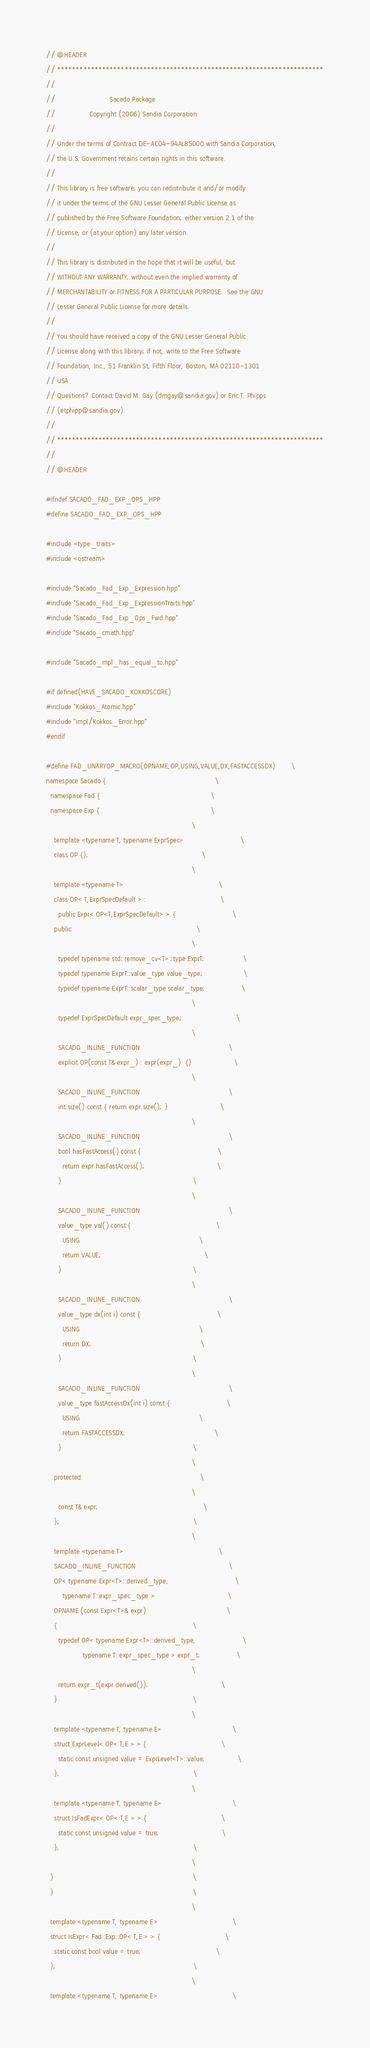<code> <loc_0><loc_0><loc_500><loc_500><_C++_>// @HEADER
// ***********************************************************************
//
//                           Sacado Package
//                 Copyright (2006) Sandia Corporation
//
// Under the terms of Contract DE-AC04-94AL85000 with Sandia Corporation,
// the U.S. Government retains certain rights in this software.
//
// This library is free software; you can redistribute it and/or modify
// it under the terms of the GNU Lesser General Public License as
// published by the Free Software Foundation; either version 2.1 of the
// License, or (at your option) any later version.
//
// This library is distributed in the hope that it will be useful, but
// WITHOUT ANY WARRANTY; without even the implied warranty of
// MERCHANTABILITY or FITNESS FOR A PARTICULAR PURPOSE.  See the GNU
// Lesser General Public License for more details.
//
// You should have received a copy of the GNU Lesser General Public
// License along with this library; if not, write to the Free Software
// Foundation, Inc., 51 Franklin St, Fifth Floor, Boston, MA 02110-1301
// USA
// Questions? Contact David M. Gay (dmgay@sandia.gov) or Eric T. Phipps
// (etphipp@sandia.gov).
//
// ***********************************************************************
//
// @HEADER

#ifndef SACADO_FAD_EXP_OPS_HPP
#define SACADO_FAD_EXP_OPS_HPP

#include <type_traits>
#include <ostream>

#include "Sacado_Fad_Exp_Expression.hpp"
#include "Sacado_Fad_Exp_ExpressionTraits.hpp"
#include "Sacado_Fad_Exp_Ops_Fwd.hpp"
#include "Sacado_cmath.hpp"

#include "Sacado_mpl_has_equal_to.hpp"

#if defined(HAVE_SACADO_KOKKOSCORE)
#include "Kokkos_Atomic.hpp"
#include "impl/Kokkos_Error.hpp"
#endif

#define FAD_UNARYOP_MACRO(OPNAME,OP,USING,VALUE,DX,FASTACCESSDX)        \
namespace Sacado {                                                      \
  namespace Fad {                                                       \
  namespace Exp {                                                       \
                                                                        \
    template <typename T, typename ExprSpec>                            \
    class OP {};                                                        \
                                                                        \
    template <typename T>                                               \
    class OP< T,ExprSpecDefault > :                                     \
      public Expr< OP<T,ExprSpecDefault> > {                            \
    public:                                                             \
                                                                        \
      typedef typename std::remove_cv<T>::type ExprT;                   \
      typedef typename ExprT::value_type value_type;                    \
      typedef typename ExprT::scalar_type scalar_type;                  \
                                                                        \
      typedef ExprSpecDefault expr_spec_type;                           \
                                                                        \
      SACADO_INLINE_FUNCTION                                            \
      explicit OP(const T& expr_) : expr(expr_)  {}                     \
                                                                        \
      SACADO_INLINE_FUNCTION                                            \
      int size() const { return expr.size(); }                          \
                                                                        \
      SACADO_INLINE_FUNCTION                                            \
      bool hasFastAccess() const {                                      \
        return expr.hasFastAccess();                                    \
      }                                                                 \
                                                                        \
      SACADO_INLINE_FUNCTION                                            \
      value_type val() const {                                          \
        USING                                                           \
        return VALUE;                                                   \
      }                                                                 \
                                                                        \
      SACADO_INLINE_FUNCTION                                            \
      value_type dx(int i) const {                                      \
        USING                                                           \
        return DX;                                                      \
      }                                                                 \
                                                                        \
      SACADO_INLINE_FUNCTION                                            \
      value_type fastAccessDx(int i) const {                            \
        USING                                                           \
        return FASTACCESSDX;                                            \
      }                                                                 \
                                                                        \
    protected:                                                          \
                                                                        \
      const T& expr;                                                    \
    };                                                                  \
                                                                        \
    template <typename T>                                               \
    SACADO_INLINE_FUNCTION                                              \
    OP< typename Expr<T>::derived_type,                                 \
        typename T::expr_spec_type >                                    \
    OPNAME (const Expr<T>& expr)                                        \
    {                                                                   \
      typedef OP< typename Expr<T>::derived_type,                       \
                  typename T::expr_spec_type > expr_t;                  \
                                                                        \
      return expr_t(expr.derived());                                    \
    }                                                                   \
                                                                        \
    template <typename T, typename E>                                   \
    struct ExprLevel< OP< T,E > > {                                     \
      static const unsigned value = ExprLevel<T>::value;                \
    };                                                                  \
                                                                        \
    template <typename T, typename E>                                   \
    struct IsFadExpr< OP< T,E > > {                                     \
      static const unsigned value = true;                               \
    };                                                                  \
                                                                        \
  }                                                                     \
  }                                                                     \
                                                                        \
  template <typename T, typename E>                                     \
  struct IsExpr< Fad::Exp::OP< T,E > > {                                \
    static const bool value = true;                                     \
  };                                                                    \
                                                                        \
  template <typename T, typename E>                                     \</code> 